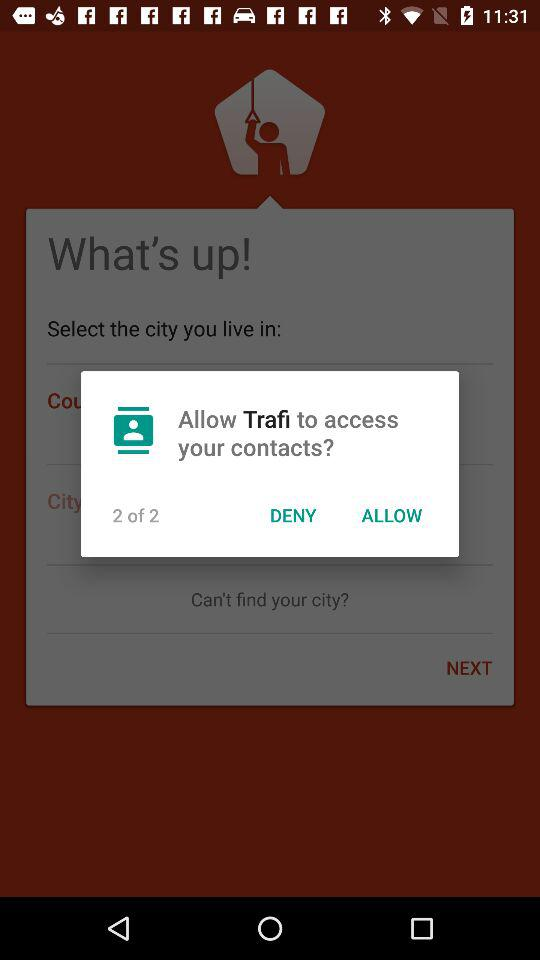Who will have access to my contacts? The application "Trafi" will have access to your contacts. 